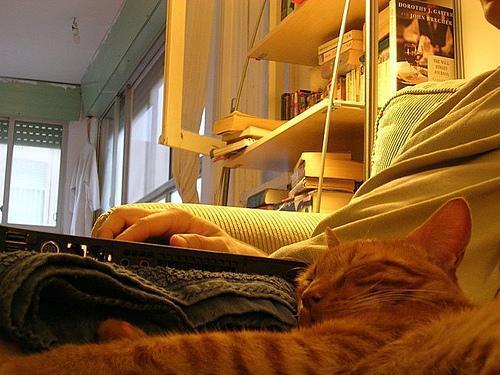How many cats are in the photo?
Give a very brief answer. 1. How many books are there?
Give a very brief answer. 2. 